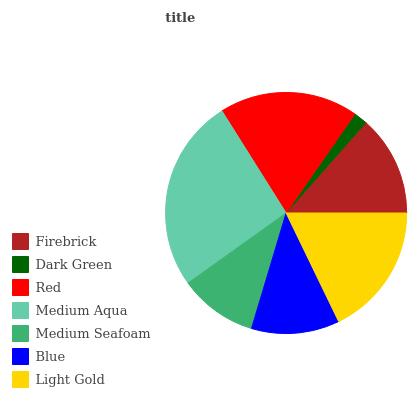Is Dark Green the minimum?
Answer yes or no. Yes. Is Medium Aqua the maximum?
Answer yes or no. Yes. Is Red the minimum?
Answer yes or no. No. Is Red the maximum?
Answer yes or no. No. Is Red greater than Dark Green?
Answer yes or no. Yes. Is Dark Green less than Red?
Answer yes or no. Yes. Is Dark Green greater than Red?
Answer yes or no. No. Is Red less than Dark Green?
Answer yes or no. No. Is Firebrick the high median?
Answer yes or no. Yes. Is Firebrick the low median?
Answer yes or no. Yes. Is Medium Seafoam the high median?
Answer yes or no. No. Is Red the low median?
Answer yes or no. No. 